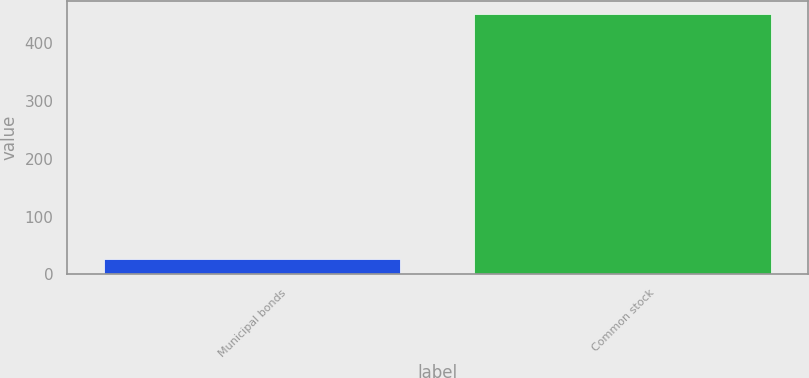Convert chart to OTSL. <chart><loc_0><loc_0><loc_500><loc_500><bar_chart><fcel>Municipal bonds<fcel>Common stock<nl><fcel>27<fcel>450<nl></chart> 